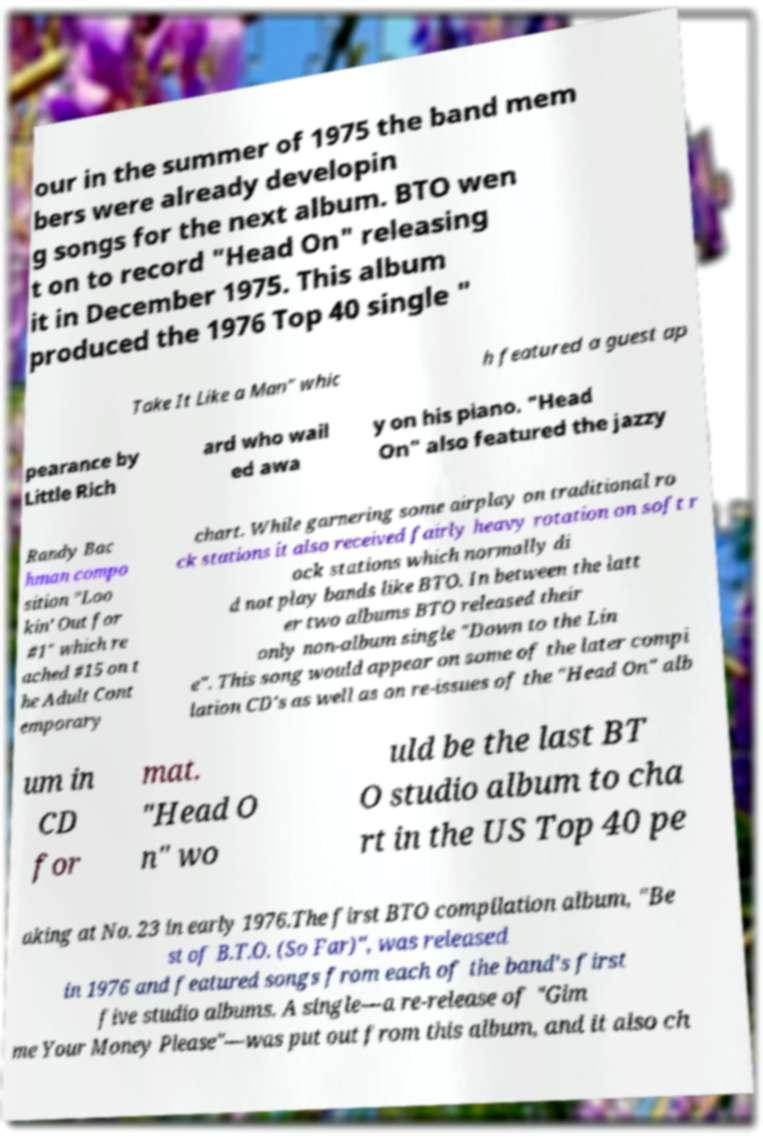Could you extract and type out the text from this image? our in the summer of 1975 the band mem bers were already developin g songs for the next album. BTO wen t on to record "Head On" releasing it in December 1975. This album produced the 1976 Top 40 single " Take It Like a Man" whic h featured a guest ap pearance by Little Rich ard who wail ed awa y on his piano. "Head On" also featured the jazzy Randy Bac hman compo sition "Loo kin' Out for #1" which re ached #15 on t he Adult Cont emporary chart. While garnering some airplay on traditional ro ck stations it also received fairly heavy rotation on soft r ock stations which normally di d not play bands like BTO. In between the latt er two albums BTO released their only non-album single "Down to the Lin e". This song would appear on some of the later compi lation CD's as well as on re-issues of the "Head On" alb um in CD for mat. "Head O n" wo uld be the last BT O studio album to cha rt in the US Top 40 pe aking at No. 23 in early 1976.The first BTO compilation album, "Be st of B.T.O. (So Far)", was released in 1976 and featured songs from each of the band's first five studio albums. A single—a re-release of "Gim me Your Money Please"—was put out from this album, and it also ch 